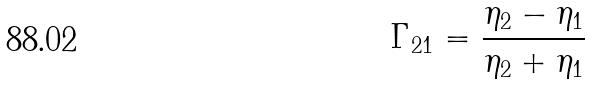Convert formula to latex. <formula><loc_0><loc_0><loc_500><loc_500>\Gamma _ { 2 1 } = \frac { \eta _ { 2 } - \eta _ { 1 } } { \eta _ { 2 } + \eta _ { 1 } }</formula> 